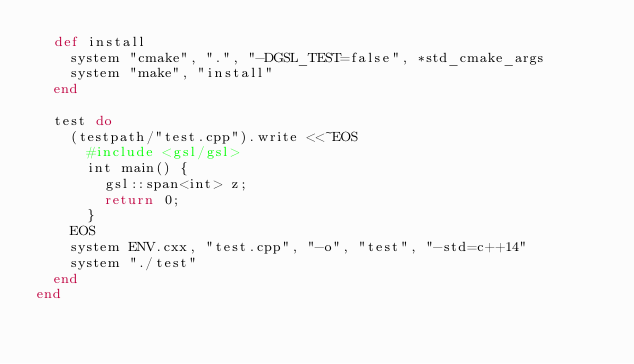Convert code to text. <code><loc_0><loc_0><loc_500><loc_500><_Ruby_>  def install
    system "cmake", ".", "-DGSL_TEST=false", *std_cmake_args
    system "make", "install"
  end

  test do
    (testpath/"test.cpp").write <<~EOS
      #include <gsl/gsl>
      int main() {
        gsl::span<int> z;
        return 0;
      }
    EOS
    system ENV.cxx, "test.cpp", "-o", "test", "-std=c++14"
    system "./test"
  end
end
</code> 